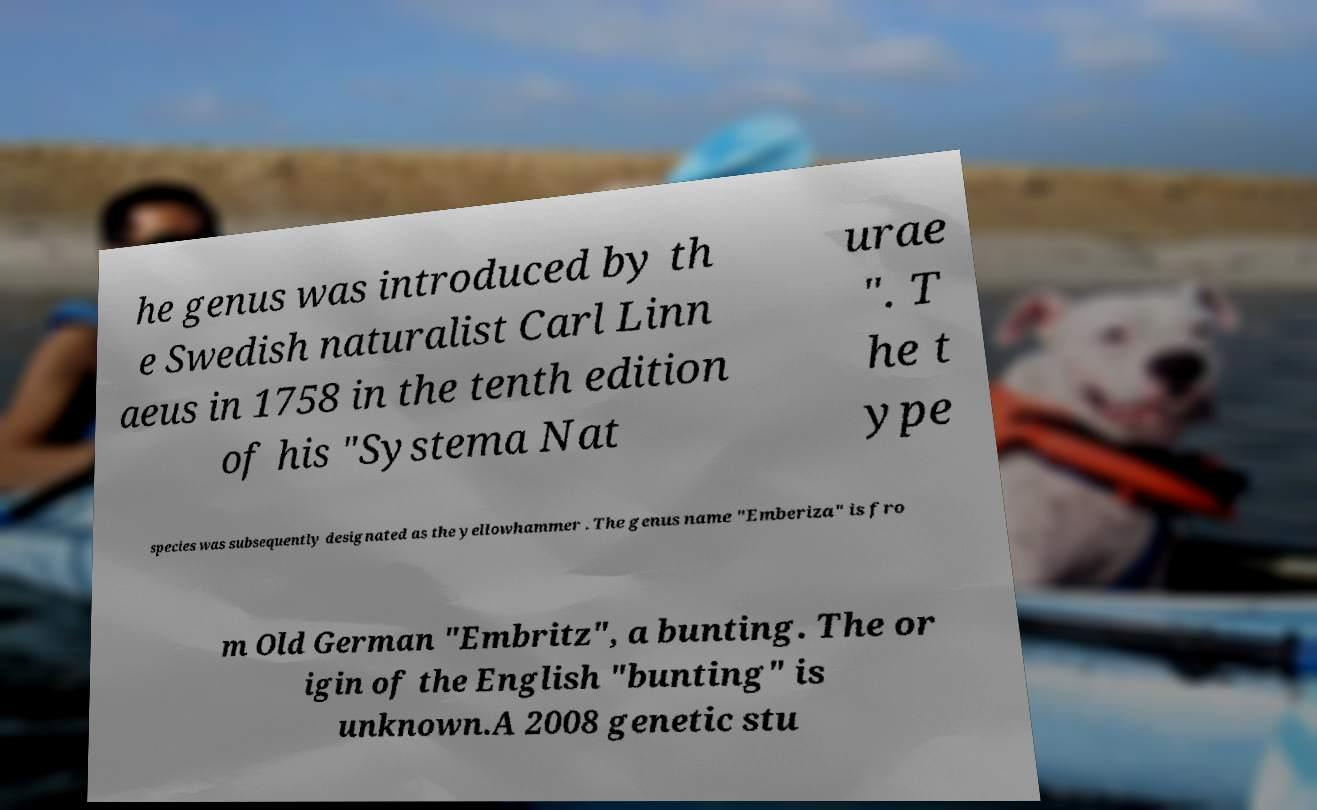Please identify and transcribe the text found in this image. he genus was introduced by th e Swedish naturalist Carl Linn aeus in 1758 in the tenth edition of his "Systema Nat urae ". T he t ype species was subsequently designated as the yellowhammer . The genus name "Emberiza" is fro m Old German "Embritz", a bunting. The or igin of the English "bunting" is unknown.A 2008 genetic stu 